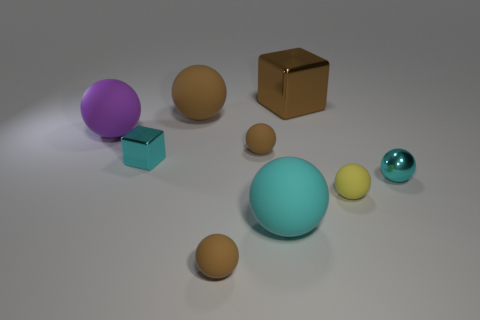Subtract all cyan metal balls. How many balls are left? 6 Subtract all cyan blocks. How many blocks are left? 1 Add 1 yellow shiny cubes. How many objects exist? 10 Subtract all blocks. How many objects are left? 7 Subtract 2 spheres. How many spheres are left? 5 Subtract all purple cubes. How many purple spheres are left? 1 Add 5 brown objects. How many brown objects are left? 9 Add 5 metal spheres. How many metal spheres exist? 6 Subtract 3 brown balls. How many objects are left? 6 Subtract all green blocks. Subtract all red cylinders. How many blocks are left? 2 